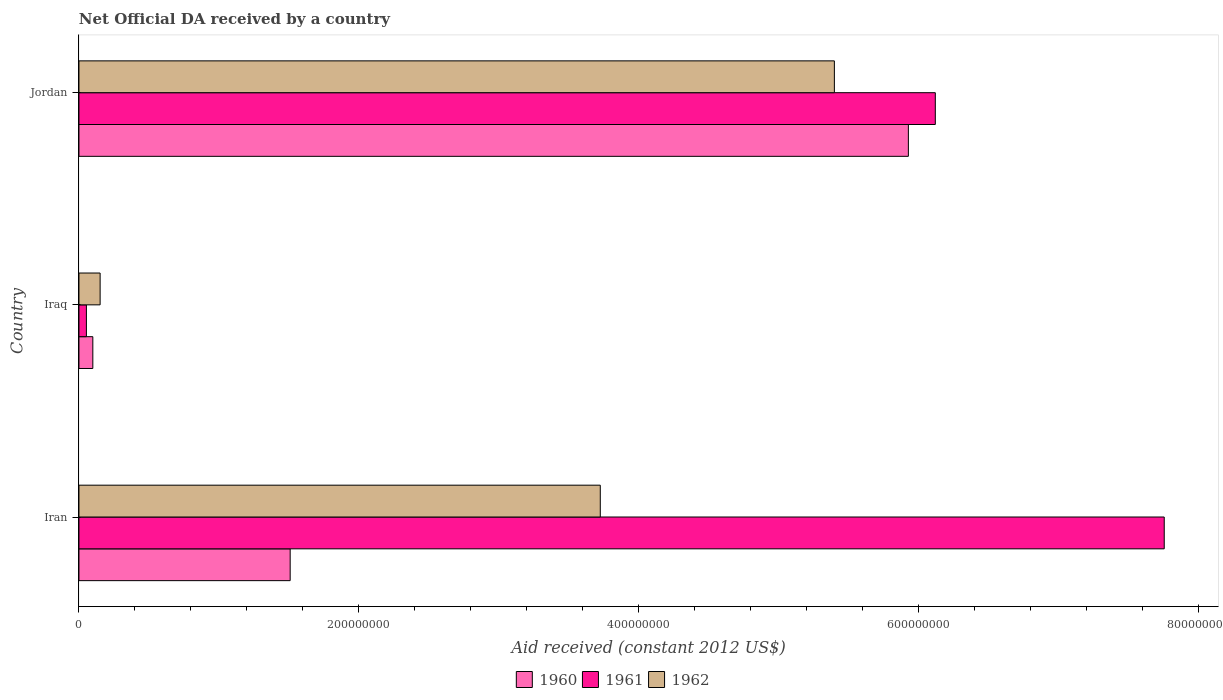How many groups of bars are there?
Make the answer very short. 3. Are the number of bars per tick equal to the number of legend labels?
Provide a succinct answer. Yes. Are the number of bars on each tick of the Y-axis equal?
Provide a short and direct response. Yes. What is the label of the 3rd group of bars from the top?
Offer a very short reply. Iran. What is the net official development assistance aid received in 1960 in Iran?
Provide a short and direct response. 1.51e+08. Across all countries, what is the maximum net official development assistance aid received in 1961?
Offer a very short reply. 7.75e+08. Across all countries, what is the minimum net official development assistance aid received in 1960?
Your response must be concise. 9.91e+06. In which country was the net official development assistance aid received in 1960 maximum?
Offer a very short reply. Jordan. In which country was the net official development assistance aid received in 1962 minimum?
Provide a short and direct response. Iraq. What is the total net official development assistance aid received in 1960 in the graph?
Keep it short and to the point. 7.53e+08. What is the difference between the net official development assistance aid received in 1961 in Iran and that in Jordan?
Give a very brief answer. 1.64e+08. What is the difference between the net official development assistance aid received in 1961 in Jordan and the net official development assistance aid received in 1962 in Iran?
Your answer should be very brief. 2.39e+08. What is the average net official development assistance aid received in 1961 per country?
Your answer should be compact. 4.64e+08. What is the difference between the net official development assistance aid received in 1962 and net official development assistance aid received in 1961 in Jordan?
Offer a terse response. -7.21e+07. In how many countries, is the net official development assistance aid received in 1961 greater than 80000000 US$?
Your response must be concise. 2. What is the ratio of the net official development assistance aid received in 1961 in Iran to that in Jordan?
Make the answer very short. 1.27. Is the difference between the net official development assistance aid received in 1962 in Iran and Iraq greater than the difference between the net official development assistance aid received in 1961 in Iran and Iraq?
Give a very brief answer. No. What is the difference between the highest and the second highest net official development assistance aid received in 1962?
Keep it short and to the point. 1.67e+08. What is the difference between the highest and the lowest net official development assistance aid received in 1960?
Ensure brevity in your answer.  5.83e+08. Is it the case that in every country, the sum of the net official development assistance aid received in 1961 and net official development assistance aid received in 1960 is greater than the net official development assistance aid received in 1962?
Keep it short and to the point. Yes. What is the difference between two consecutive major ticks on the X-axis?
Your answer should be compact. 2.00e+08. Does the graph contain any zero values?
Keep it short and to the point. No. Does the graph contain grids?
Offer a very short reply. No. How are the legend labels stacked?
Provide a short and direct response. Horizontal. What is the title of the graph?
Provide a succinct answer. Net Official DA received by a country. What is the label or title of the X-axis?
Ensure brevity in your answer.  Aid received (constant 2012 US$). What is the label or title of the Y-axis?
Provide a short and direct response. Country. What is the Aid received (constant 2012 US$) in 1960 in Iran?
Provide a succinct answer. 1.51e+08. What is the Aid received (constant 2012 US$) in 1961 in Iran?
Offer a terse response. 7.75e+08. What is the Aid received (constant 2012 US$) in 1962 in Iran?
Your answer should be very brief. 3.73e+08. What is the Aid received (constant 2012 US$) in 1960 in Iraq?
Make the answer very short. 9.91e+06. What is the Aid received (constant 2012 US$) in 1961 in Iraq?
Your response must be concise. 5.33e+06. What is the Aid received (constant 2012 US$) in 1962 in Iraq?
Offer a very short reply. 1.51e+07. What is the Aid received (constant 2012 US$) in 1960 in Jordan?
Provide a succinct answer. 5.93e+08. What is the Aid received (constant 2012 US$) in 1961 in Jordan?
Offer a very short reply. 6.12e+08. What is the Aid received (constant 2012 US$) of 1962 in Jordan?
Your response must be concise. 5.40e+08. Across all countries, what is the maximum Aid received (constant 2012 US$) of 1960?
Your answer should be very brief. 5.93e+08. Across all countries, what is the maximum Aid received (constant 2012 US$) of 1961?
Provide a short and direct response. 7.75e+08. Across all countries, what is the maximum Aid received (constant 2012 US$) in 1962?
Provide a short and direct response. 5.40e+08. Across all countries, what is the minimum Aid received (constant 2012 US$) of 1960?
Make the answer very short. 9.91e+06. Across all countries, what is the minimum Aid received (constant 2012 US$) in 1961?
Make the answer very short. 5.33e+06. Across all countries, what is the minimum Aid received (constant 2012 US$) in 1962?
Ensure brevity in your answer.  1.51e+07. What is the total Aid received (constant 2012 US$) of 1960 in the graph?
Your answer should be very brief. 7.53e+08. What is the total Aid received (constant 2012 US$) of 1961 in the graph?
Offer a terse response. 1.39e+09. What is the total Aid received (constant 2012 US$) in 1962 in the graph?
Your answer should be very brief. 9.27e+08. What is the difference between the Aid received (constant 2012 US$) of 1960 in Iran and that in Iraq?
Provide a succinct answer. 1.41e+08. What is the difference between the Aid received (constant 2012 US$) in 1961 in Iran and that in Iraq?
Your answer should be compact. 7.70e+08. What is the difference between the Aid received (constant 2012 US$) of 1962 in Iran and that in Iraq?
Your answer should be compact. 3.57e+08. What is the difference between the Aid received (constant 2012 US$) of 1960 in Iran and that in Jordan?
Offer a terse response. -4.42e+08. What is the difference between the Aid received (constant 2012 US$) in 1961 in Iran and that in Jordan?
Offer a very short reply. 1.64e+08. What is the difference between the Aid received (constant 2012 US$) in 1962 in Iran and that in Jordan?
Offer a terse response. -1.67e+08. What is the difference between the Aid received (constant 2012 US$) of 1960 in Iraq and that in Jordan?
Provide a short and direct response. -5.83e+08. What is the difference between the Aid received (constant 2012 US$) of 1961 in Iraq and that in Jordan?
Offer a terse response. -6.07e+08. What is the difference between the Aid received (constant 2012 US$) in 1962 in Iraq and that in Jordan?
Provide a succinct answer. -5.25e+08. What is the difference between the Aid received (constant 2012 US$) in 1960 in Iran and the Aid received (constant 2012 US$) in 1961 in Iraq?
Your response must be concise. 1.46e+08. What is the difference between the Aid received (constant 2012 US$) of 1960 in Iran and the Aid received (constant 2012 US$) of 1962 in Iraq?
Your response must be concise. 1.36e+08. What is the difference between the Aid received (constant 2012 US$) in 1961 in Iran and the Aid received (constant 2012 US$) in 1962 in Iraq?
Offer a very short reply. 7.60e+08. What is the difference between the Aid received (constant 2012 US$) of 1960 in Iran and the Aid received (constant 2012 US$) of 1961 in Jordan?
Your response must be concise. -4.61e+08. What is the difference between the Aid received (constant 2012 US$) of 1960 in Iran and the Aid received (constant 2012 US$) of 1962 in Jordan?
Provide a short and direct response. -3.89e+08. What is the difference between the Aid received (constant 2012 US$) in 1961 in Iran and the Aid received (constant 2012 US$) in 1962 in Jordan?
Ensure brevity in your answer.  2.36e+08. What is the difference between the Aid received (constant 2012 US$) of 1960 in Iraq and the Aid received (constant 2012 US$) of 1961 in Jordan?
Your response must be concise. -6.02e+08. What is the difference between the Aid received (constant 2012 US$) of 1960 in Iraq and the Aid received (constant 2012 US$) of 1962 in Jordan?
Make the answer very short. -5.30e+08. What is the difference between the Aid received (constant 2012 US$) in 1961 in Iraq and the Aid received (constant 2012 US$) in 1962 in Jordan?
Offer a very short reply. -5.34e+08. What is the average Aid received (constant 2012 US$) of 1960 per country?
Your response must be concise. 2.51e+08. What is the average Aid received (constant 2012 US$) of 1961 per country?
Provide a succinct answer. 4.64e+08. What is the average Aid received (constant 2012 US$) in 1962 per country?
Offer a very short reply. 3.09e+08. What is the difference between the Aid received (constant 2012 US$) in 1960 and Aid received (constant 2012 US$) in 1961 in Iran?
Make the answer very short. -6.25e+08. What is the difference between the Aid received (constant 2012 US$) in 1960 and Aid received (constant 2012 US$) in 1962 in Iran?
Keep it short and to the point. -2.22e+08. What is the difference between the Aid received (constant 2012 US$) in 1961 and Aid received (constant 2012 US$) in 1962 in Iran?
Provide a succinct answer. 4.03e+08. What is the difference between the Aid received (constant 2012 US$) of 1960 and Aid received (constant 2012 US$) of 1961 in Iraq?
Offer a terse response. 4.58e+06. What is the difference between the Aid received (constant 2012 US$) of 1960 and Aid received (constant 2012 US$) of 1962 in Iraq?
Offer a very short reply. -5.22e+06. What is the difference between the Aid received (constant 2012 US$) in 1961 and Aid received (constant 2012 US$) in 1962 in Iraq?
Give a very brief answer. -9.80e+06. What is the difference between the Aid received (constant 2012 US$) of 1960 and Aid received (constant 2012 US$) of 1961 in Jordan?
Offer a terse response. -1.92e+07. What is the difference between the Aid received (constant 2012 US$) in 1960 and Aid received (constant 2012 US$) in 1962 in Jordan?
Offer a very short reply. 5.29e+07. What is the difference between the Aid received (constant 2012 US$) in 1961 and Aid received (constant 2012 US$) in 1962 in Jordan?
Your response must be concise. 7.21e+07. What is the ratio of the Aid received (constant 2012 US$) in 1960 in Iran to that in Iraq?
Provide a short and direct response. 15.23. What is the ratio of the Aid received (constant 2012 US$) of 1961 in Iran to that in Iraq?
Offer a very short reply. 145.49. What is the ratio of the Aid received (constant 2012 US$) in 1962 in Iran to that in Iraq?
Offer a very short reply. 24.62. What is the ratio of the Aid received (constant 2012 US$) of 1960 in Iran to that in Jordan?
Your answer should be compact. 0.25. What is the ratio of the Aid received (constant 2012 US$) in 1961 in Iran to that in Jordan?
Offer a very short reply. 1.27. What is the ratio of the Aid received (constant 2012 US$) of 1962 in Iran to that in Jordan?
Your response must be concise. 0.69. What is the ratio of the Aid received (constant 2012 US$) of 1960 in Iraq to that in Jordan?
Offer a very short reply. 0.02. What is the ratio of the Aid received (constant 2012 US$) in 1961 in Iraq to that in Jordan?
Your response must be concise. 0.01. What is the ratio of the Aid received (constant 2012 US$) of 1962 in Iraq to that in Jordan?
Ensure brevity in your answer.  0.03. What is the difference between the highest and the second highest Aid received (constant 2012 US$) in 1960?
Provide a succinct answer. 4.42e+08. What is the difference between the highest and the second highest Aid received (constant 2012 US$) of 1961?
Keep it short and to the point. 1.64e+08. What is the difference between the highest and the second highest Aid received (constant 2012 US$) in 1962?
Provide a short and direct response. 1.67e+08. What is the difference between the highest and the lowest Aid received (constant 2012 US$) in 1960?
Your answer should be very brief. 5.83e+08. What is the difference between the highest and the lowest Aid received (constant 2012 US$) of 1961?
Provide a short and direct response. 7.70e+08. What is the difference between the highest and the lowest Aid received (constant 2012 US$) in 1962?
Offer a very short reply. 5.25e+08. 